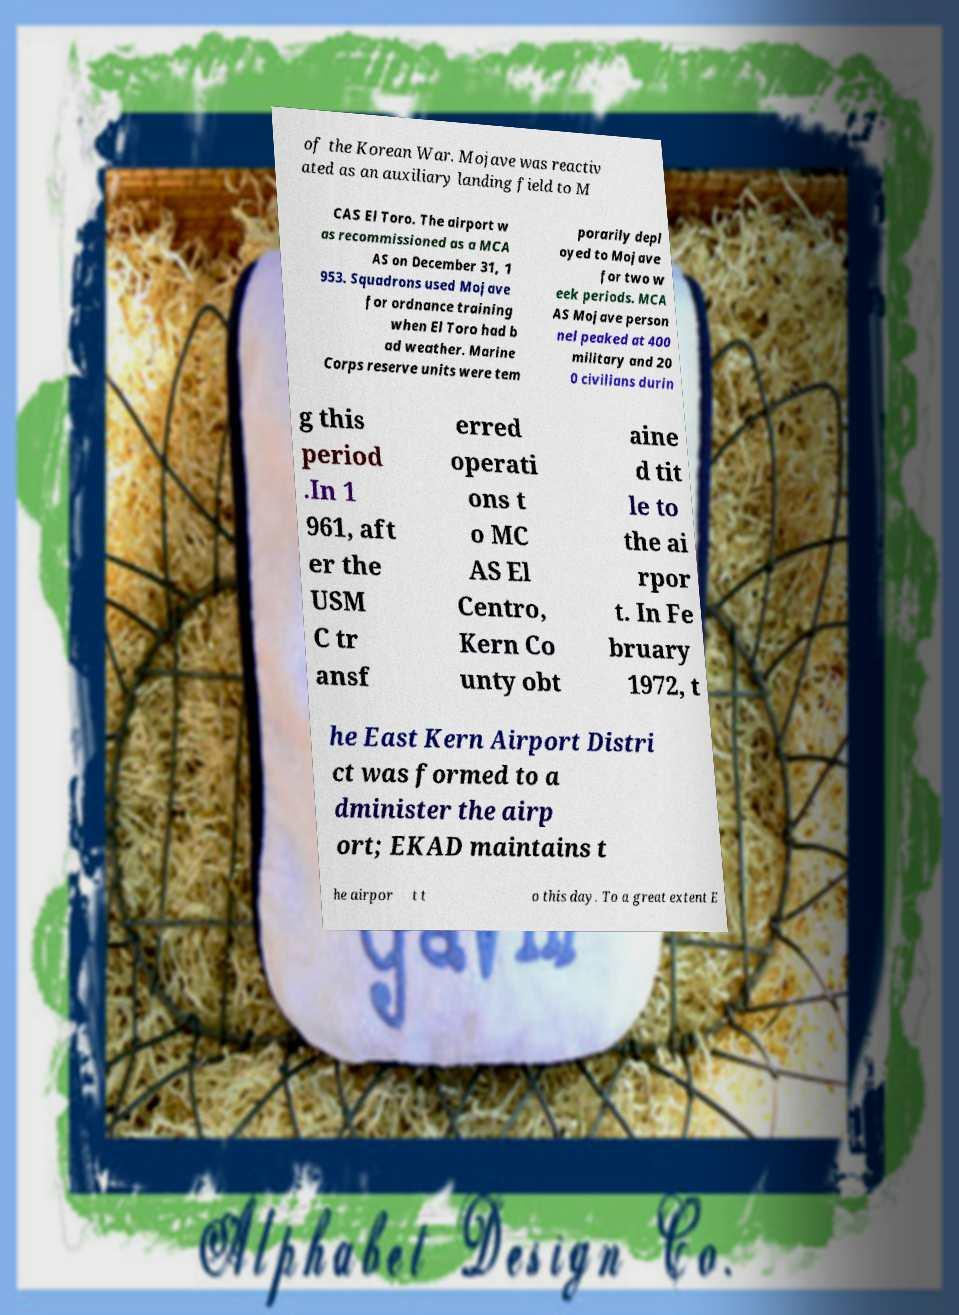I need the written content from this picture converted into text. Can you do that? of the Korean War. Mojave was reactiv ated as an auxiliary landing field to M CAS El Toro. The airport w as recommissioned as a MCA AS on December 31, 1 953. Squadrons used Mojave for ordnance training when El Toro had b ad weather. Marine Corps reserve units were tem porarily depl oyed to Mojave for two w eek periods. MCA AS Mojave person nel peaked at 400 military and 20 0 civilians durin g this period .In 1 961, aft er the USM C tr ansf erred operati ons t o MC AS El Centro, Kern Co unty obt aine d tit le to the ai rpor t. In Fe bruary 1972, t he East Kern Airport Distri ct was formed to a dminister the airp ort; EKAD maintains t he airpor t t o this day. To a great extent E 